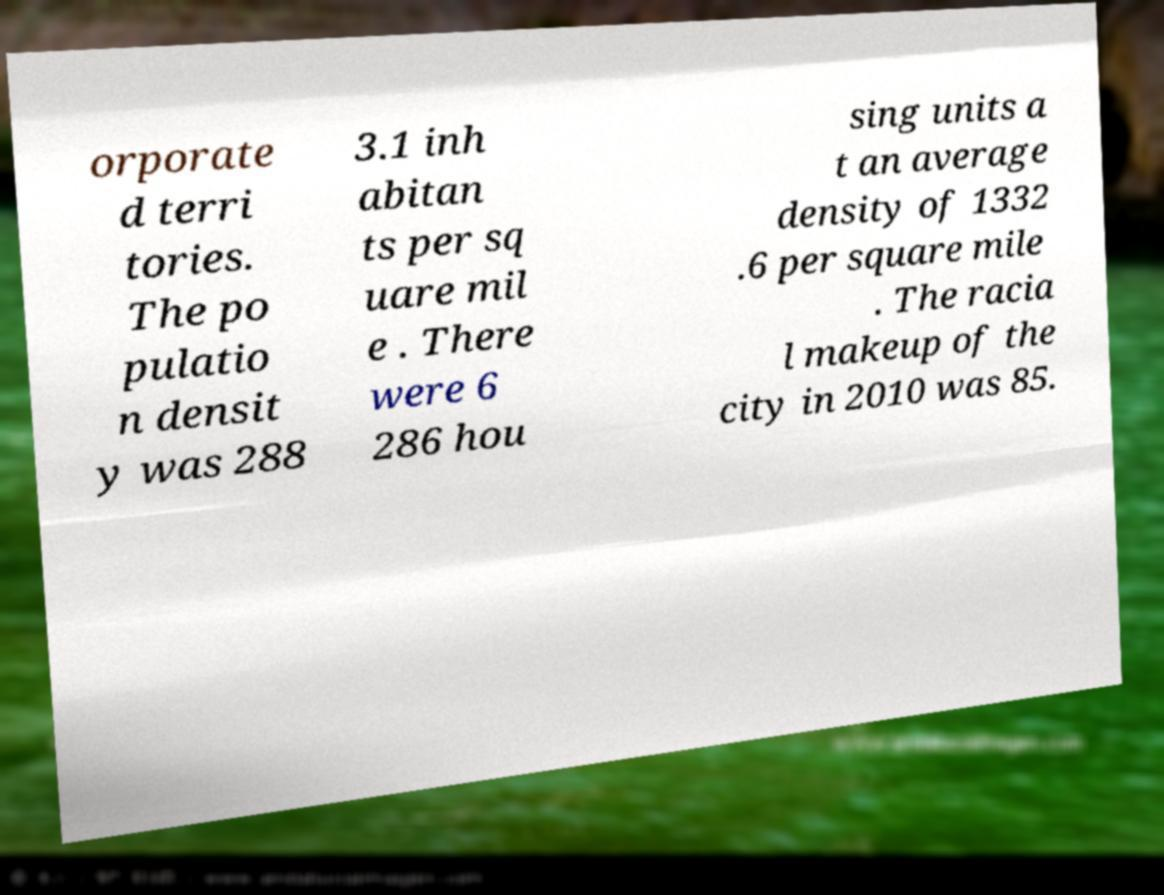For documentation purposes, I need the text within this image transcribed. Could you provide that? orporate d terri tories. The po pulatio n densit y was 288 3.1 inh abitan ts per sq uare mil e . There were 6 286 hou sing units a t an average density of 1332 .6 per square mile . The racia l makeup of the city in 2010 was 85. 